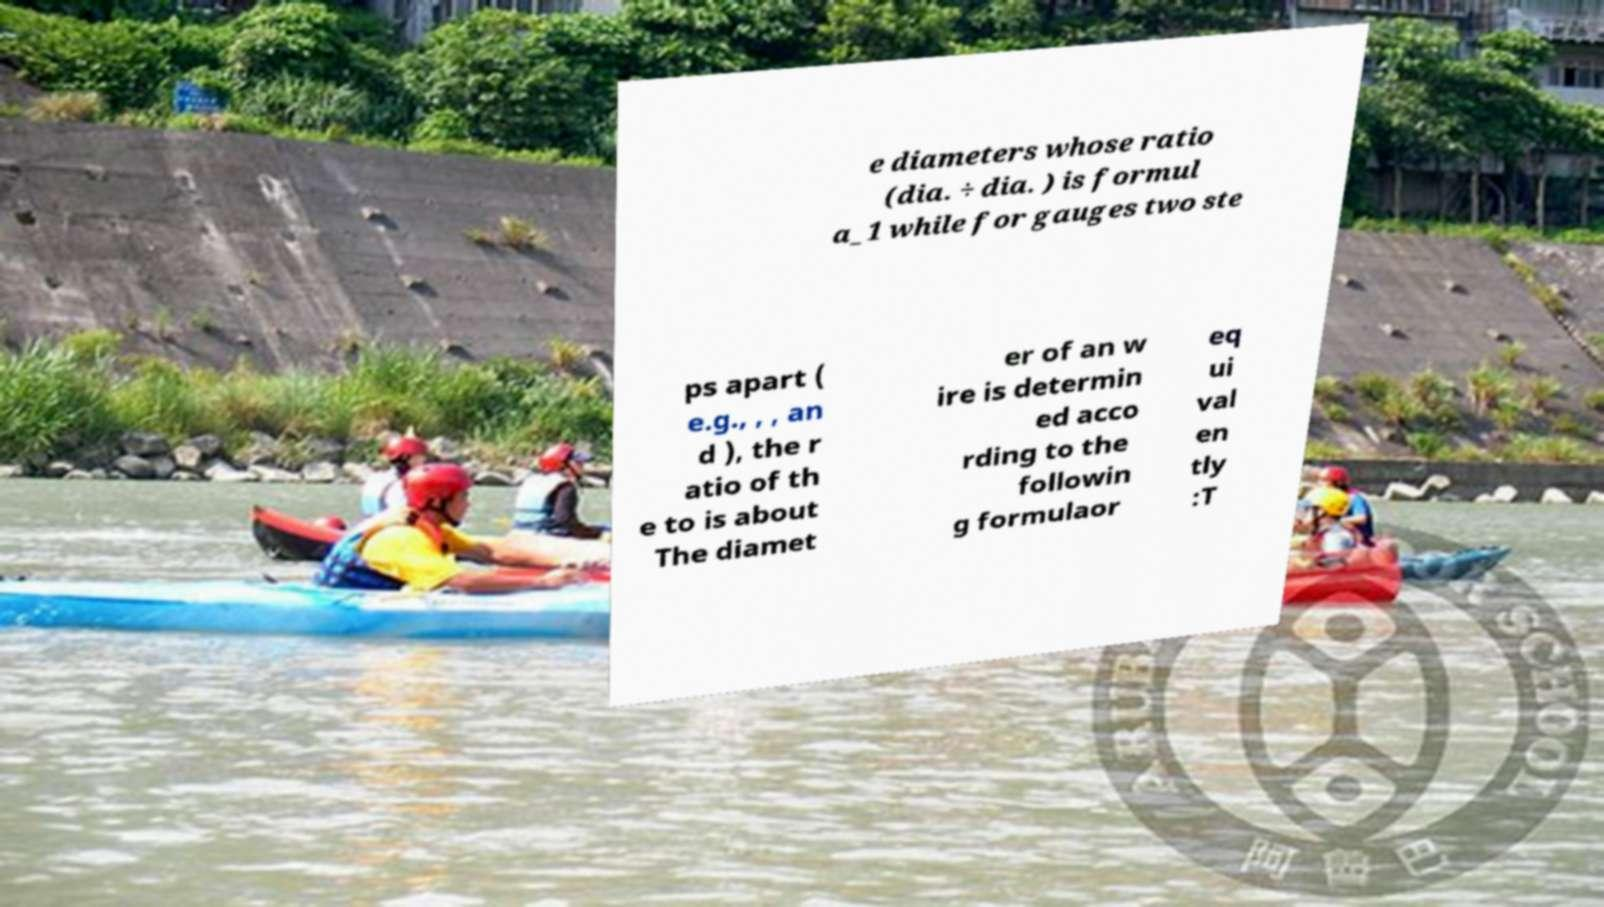What messages or text are displayed in this image? I need them in a readable, typed format. e diameters whose ratio (dia. ÷ dia. ) is formul a_1 while for gauges two ste ps apart ( e.g., , , an d ), the r atio of th e to is about The diamet er of an w ire is determin ed acco rding to the followin g formulaor eq ui val en tly :T 